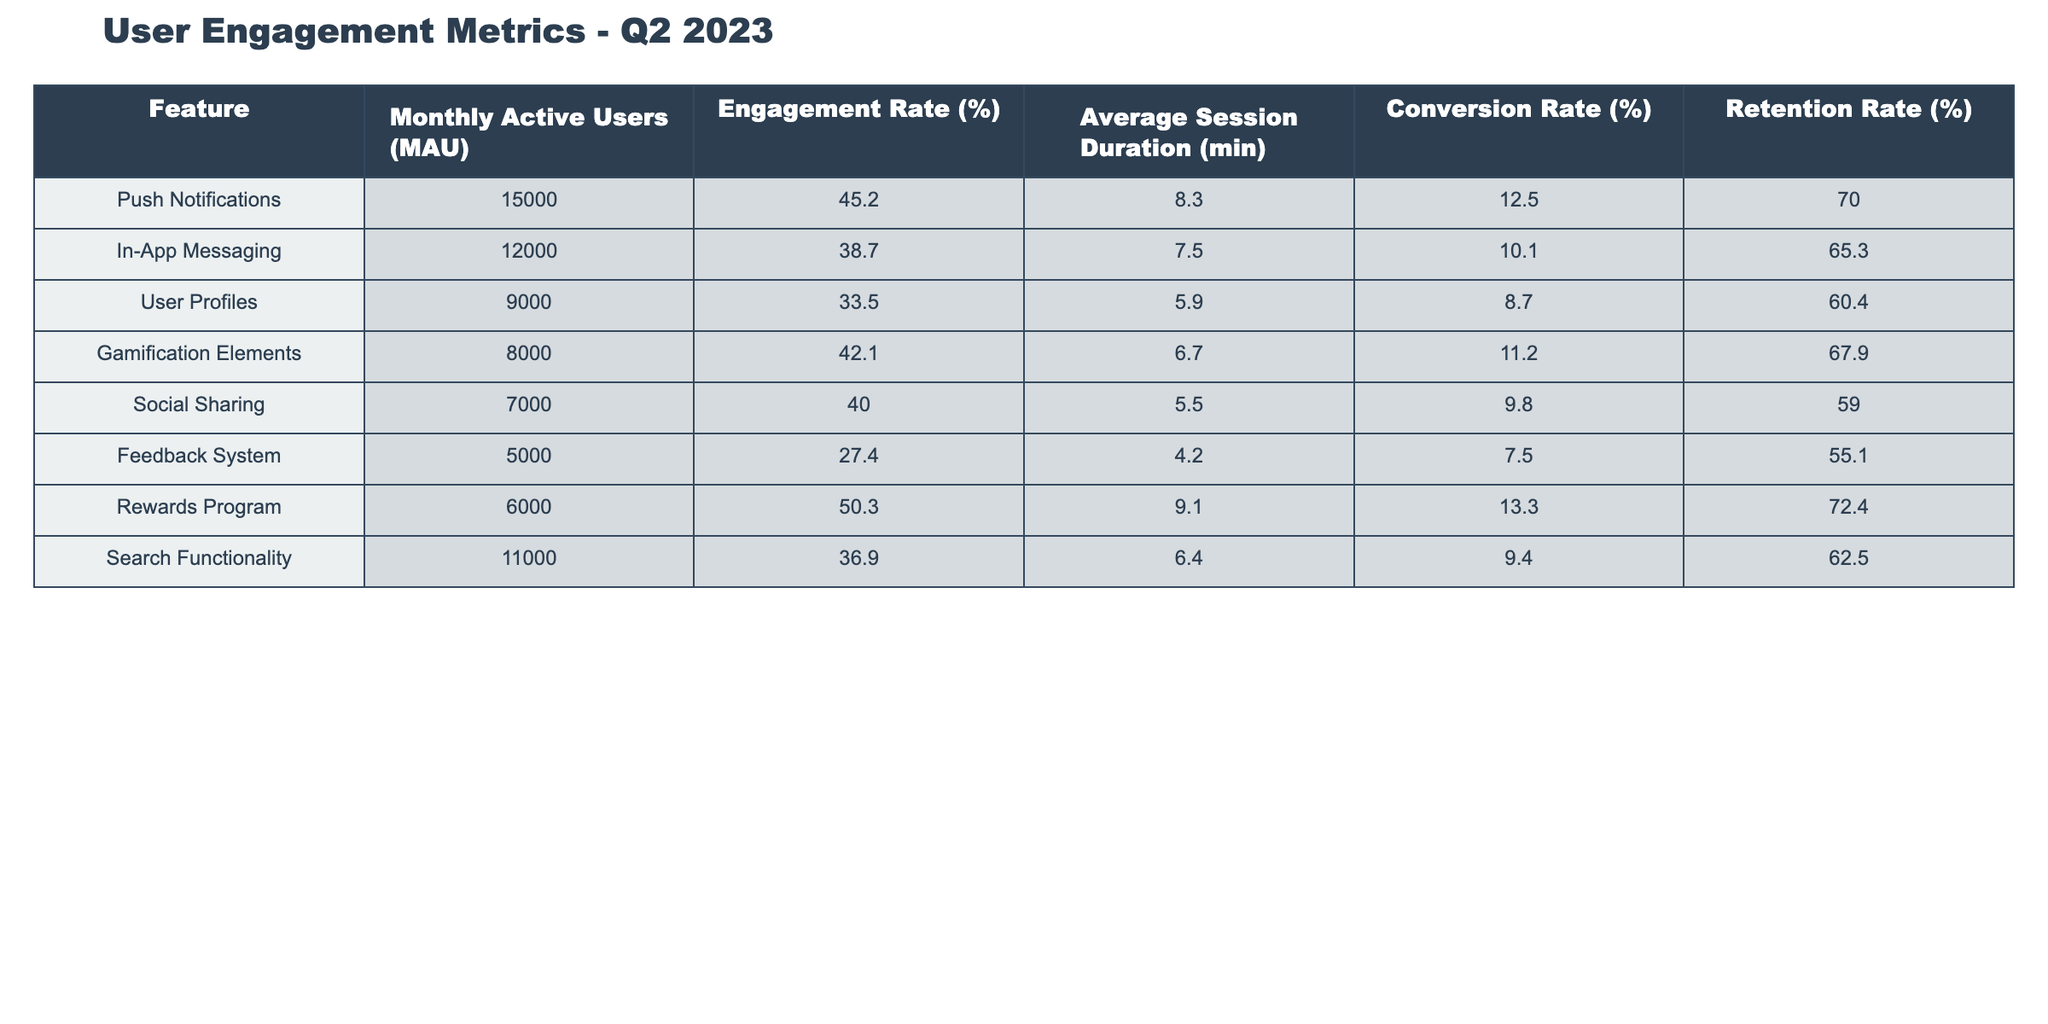What is the engagement rate for Push Notifications? The engagement rate for Push Notifications can be directly found in the table under the Engagement Rate (%) column. It is listed as 45.2%.
Answer: 45.2% Which feature has the highest conversion rate? In the table, the Conversion Rate (%) column reveals that the Rewards Program has the highest conversion rate at 13.3%.
Answer: Rewards Program What is the average session duration for the features that have a conversion rate above 10%? To find the average session duration for features with a conversion rate above 10%, we need to identify these features: Push Notifications (8.3 min), Gamification Elements (6.7 min), and Rewards Program (9.1 min). Adding these durations gives 8.3 + 6.7 + 9.1 = 24.1 min, and dividing by the number of features (3) yields an average of 24.1 / 3 = 8.03 min.
Answer: 8.03 min Is the Retention Rate for the Feedback System higher than 60%? The Retention Rate (%) for the Feedback System is listed as 55.1%, which is lower than 60%. Therefore, the statement is false.
Answer: No How does the Engagement Rate of User Profiles compare to that of Social Sharing? The Engagement Rate for User Profiles is 33.5% and for Social Sharing it is 40.0%. Since 40.0% is higher than 33.5%, we can say that the Engagement Rate for Social Sharing is greater than that for User Profiles.
Answer: Social Sharing engagement rate is higher 